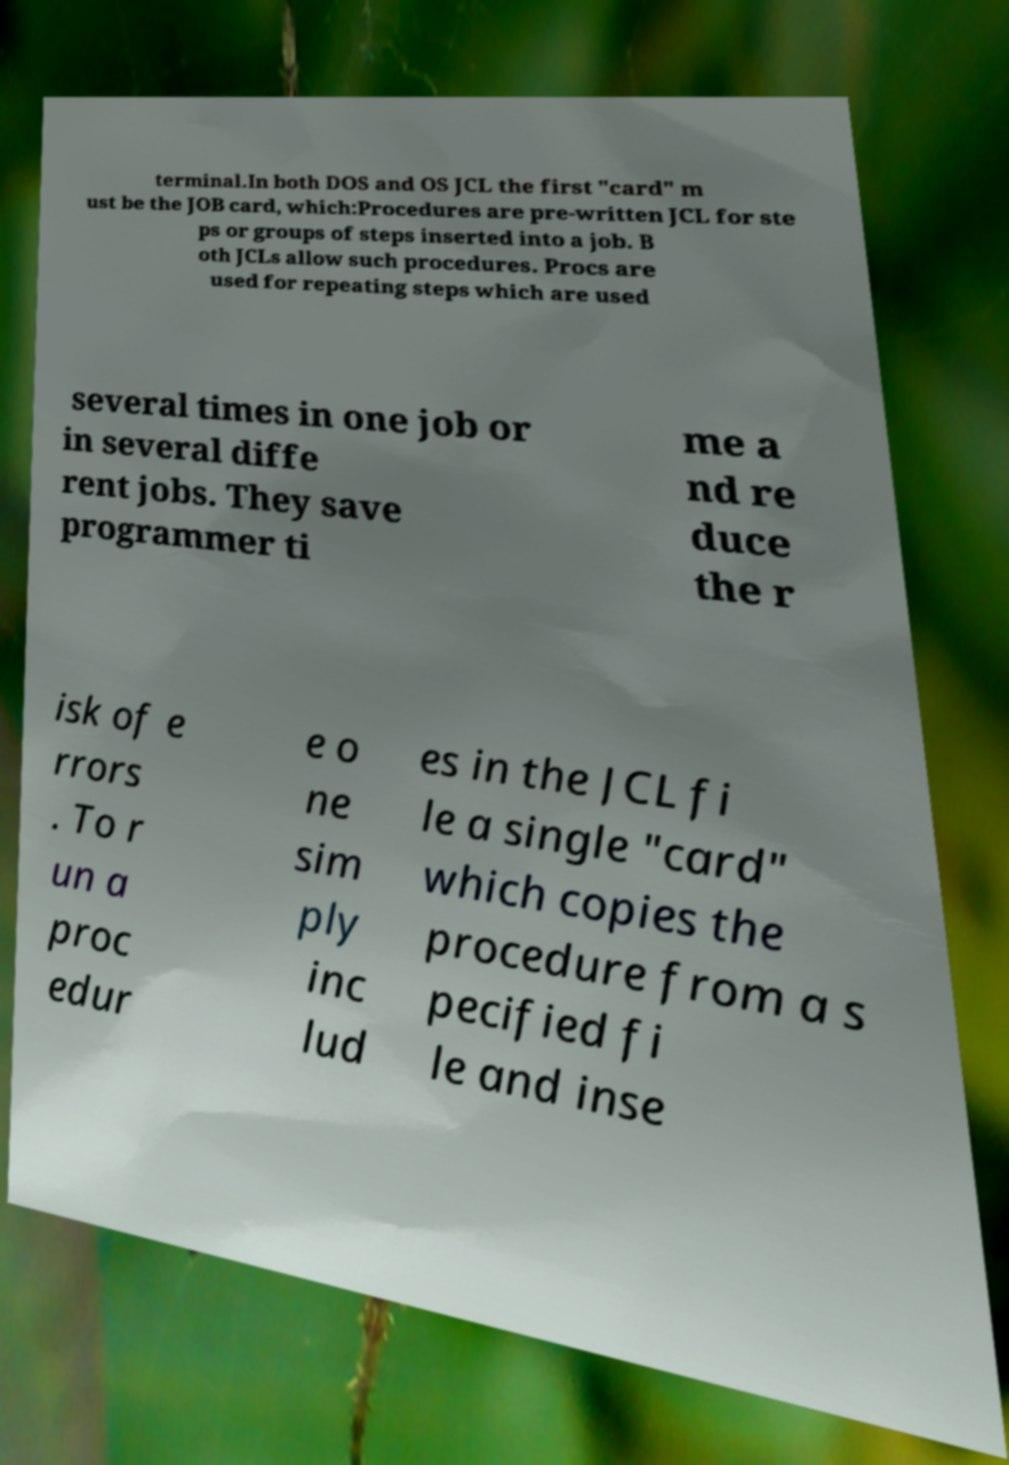I need the written content from this picture converted into text. Can you do that? terminal.In both DOS and OS JCL the first "card" m ust be the JOB card, which:Procedures are pre-written JCL for ste ps or groups of steps inserted into a job. B oth JCLs allow such procedures. Procs are used for repeating steps which are used several times in one job or in several diffe rent jobs. They save programmer ti me a nd re duce the r isk of e rrors . To r un a proc edur e o ne sim ply inc lud es in the JCL fi le a single "card" which copies the procedure from a s pecified fi le and inse 